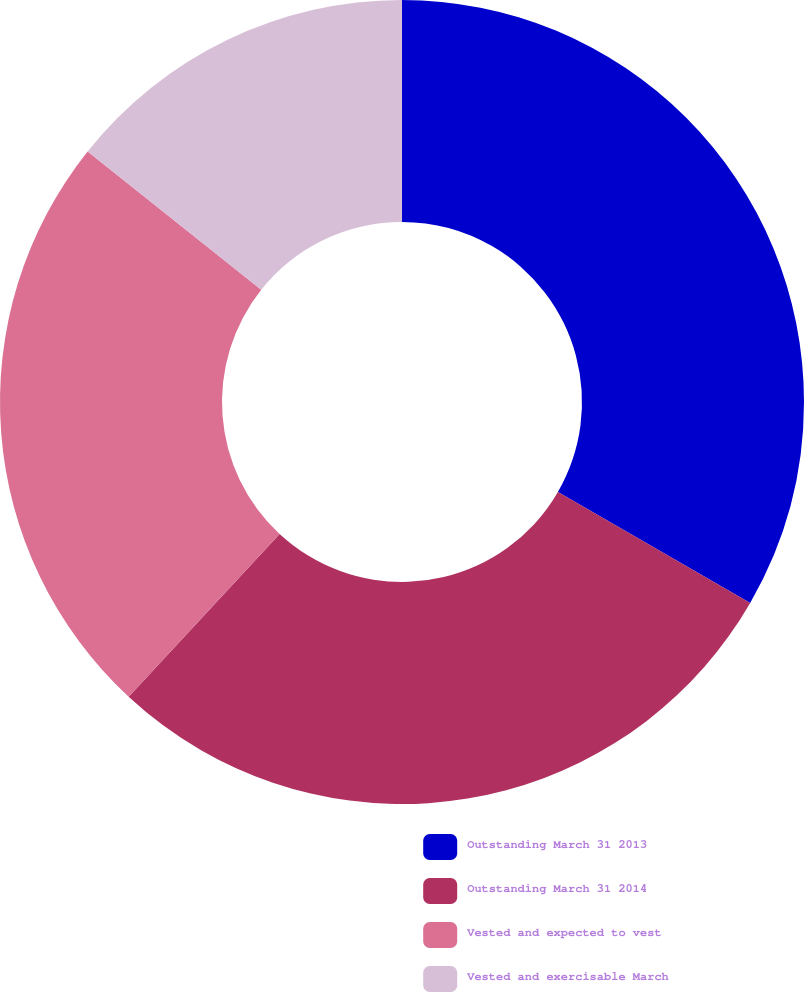<chart> <loc_0><loc_0><loc_500><loc_500><pie_chart><fcel>Outstanding March 31 2013<fcel>Outstanding March 31 2014<fcel>Vested and expected to vest<fcel>Vested and exercisable March<nl><fcel>33.33%<fcel>28.57%<fcel>23.81%<fcel>14.29%<nl></chart> 